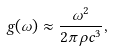Convert formula to latex. <formula><loc_0><loc_0><loc_500><loc_500>g ( \omega ) \approx \frac { \omega ^ { 2 } } { 2 \pi \rho c ^ { 3 } } ,</formula> 